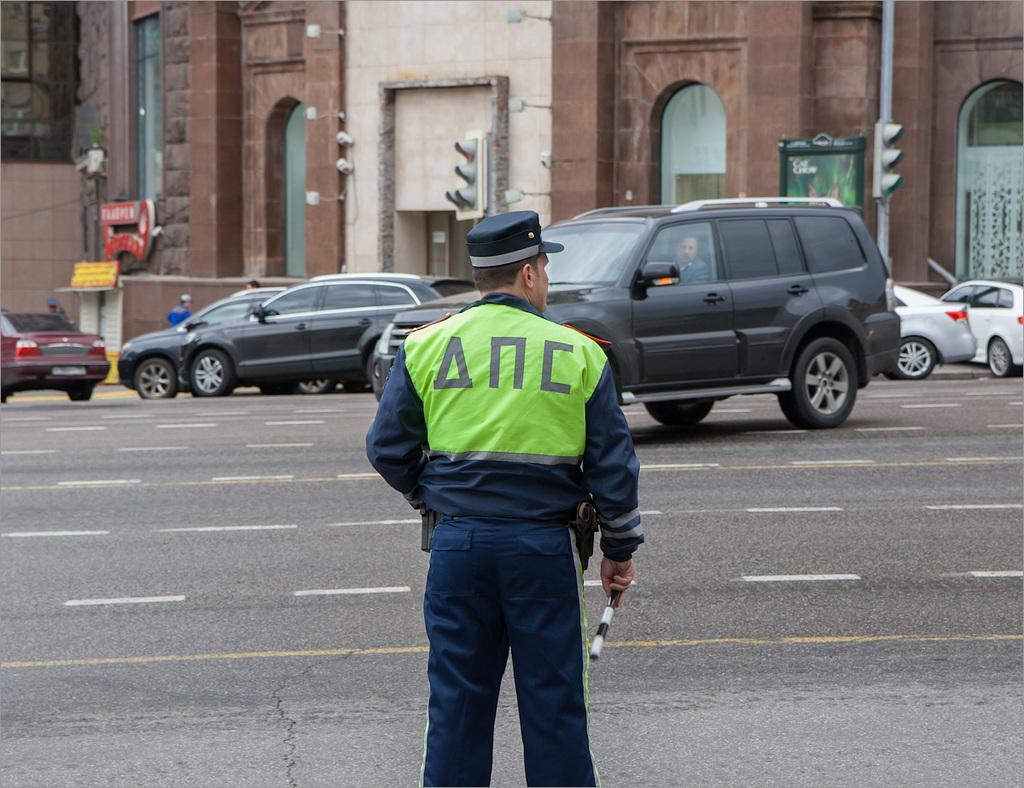Can you describe this image briefly? We can able to see a person is standing and vehicles on road. Inside this vehicle a person is sitting. This is a building. These are signal poles. Far these persons are standing. 